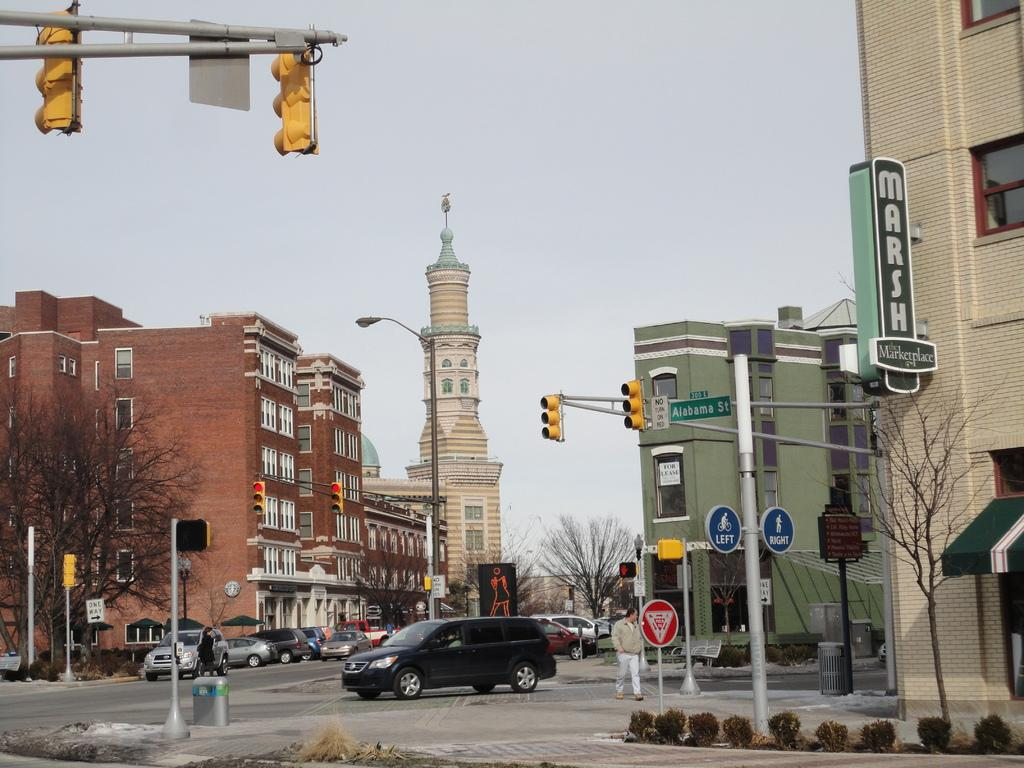Provide a one-sentence caption for the provided image. A street view of a Marketplace named "MARSH". 